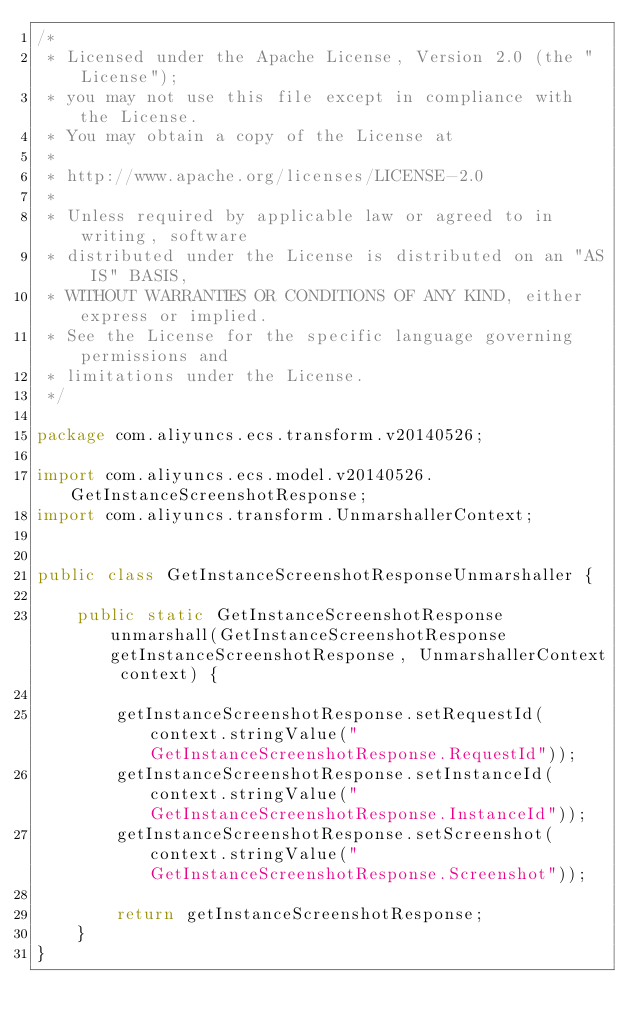<code> <loc_0><loc_0><loc_500><loc_500><_Java_>/*
 * Licensed under the Apache License, Version 2.0 (the "License");
 * you may not use this file except in compliance with the License.
 * You may obtain a copy of the License at
 *
 * http://www.apache.org/licenses/LICENSE-2.0
 *
 * Unless required by applicable law or agreed to in writing, software
 * distributed under the License is distributed on an "AS IS" BASIS,
 * WITHOUT WARRANTIES OR CONDITIONS OF ANY KIND, either express or implied.
 * See the License for the specific language governing permissions and
 * limitations under the License.
 */

package com.aliyuncs.ecs.transform.v20140526;

import com.aliyuncs.ecs.model.v20140526.GetInstanceScreenshotResponse;
import com.aliyuncs.transform.UnmarshallerContext;


public class GetInstanceScreenshotResponseUnmarshaller {

	public static GetInstanceScreenshotResponse unmarshall(GetInstanceScreenshotResponse getInstanceScreenshotResponse, UnmarshallerContext context) {
		
		getInstanceScreenshotResponse.setRequestId(context.stringValue("GetInstanceScreenshotResponse.RequestId"));
		getInstanceScreenshotResponse.setInstanceId(context.stringValue("GetInstanceScreenshotResponse.InstanceId"));
		getInstanceScreenshotResponse.setScreenshot(context.stringValue("GetInstanceScreenshotResponse.Screenshot"));
	 
	 	return getInstanceScreenshotResponse;
	}
}</code> 